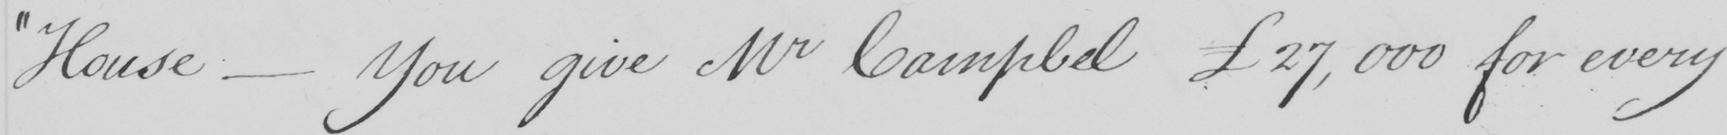Can you read and transcribe this handwriting? " House  _  You give Mr Campbell £27,000 for every 